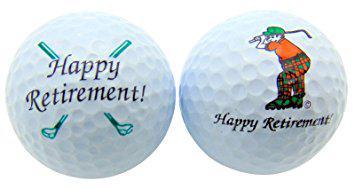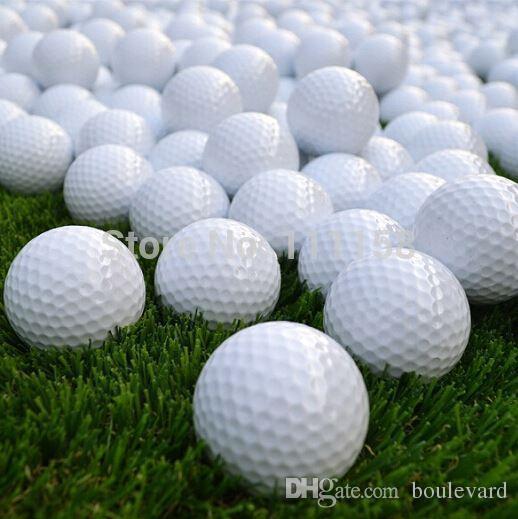The first image is the image on the left, the second image is the image on the right. For the images shown, is this caption "The balls in at least one of the images are set on the grass." true? Answer yes or no. Yes. 